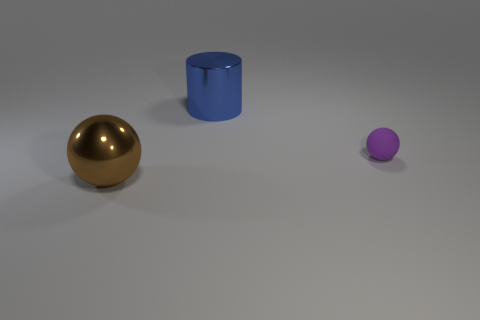Are there fewer big blue spheres than tiny rubber things?
Your answer should be compact. Yes. How many objects are the same size as the blue metallic cylinder?
Offer a very short reply. 1. What is the material of the big blue thing?
Keep it short and to the point. Metal. What is the size of the thing in front of the small purple object?
Ensure brevity in your answer.  Large. What number of small objects are the same shape as the big brown metallic object?
Your answer should be compact. 1. There is a large object that is the same material as the large brown ball; what is its shape?
Keep it short and to the point. Cylinder. What number of brown objects are either tiny spheres or big balls?
Offer a very short reply. 1. There is a purple matte thing; are there any metallic spheres right of it?
Offer a very short reply. No. Is the shape of the metal thing that is behind the rubber ball the same as the object left of the big blue shiny thing?
Your response must be concise. No. There is another object that is the same shape as the purple object; what is it made of?
Provide a succinct answer. Metal. 